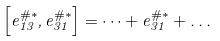<formula> <loc_0><loc_0><loc_500><loc_500>\left [ e _ { 1 3 } ^ { \# \ast } , e _ { 3 1 } ^ { \# \ast } \right ] = \dots + e _ { 3 1 } ^ { \# \ast } + \dots</formula> 